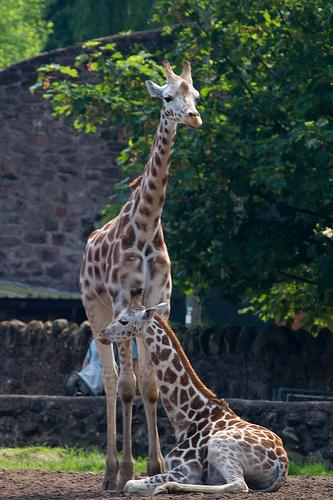Describe the background elements in the image, such as the walls and vegetation. The background features a wall of rock and a stone fence, some green grass next to the wall, an arched stone wall, trees and leaves, and metal poles or pipes. What are the objects located behind the main subject (giraffes) in the image? Behind the giraffes, there is a person, green grass, trees, metal poles or pipes, and a stone wall with possible stone buildings. Specify the key areas of interest in the image and their significance. Key areas of interest include the giraffes, which are the main subjects, the person observing them from behind, and the stone wall and trees with green leaves that set the natural context for the scene. What actions or emotions are expressed by the giraffes in the image? One giraffe is laying on the ground and appears tired or resting, while the other giraffe is standing on the ground. Mention any noteworthy colors and textures present in the image. Brown spots and patterning on the giraffes, green leaves and grass, gray and dark tones in the stone walls, black dirt on the ground, and metallic appearance in the pipes or poles. Provide a brief description of the overall scene in the image. The image features two giraffes near each other, one standing and one laying on the ground in a brown dirt area, surrounded by trees, grass, and a stone wall, with a person and metallic elements visible behind. What type of ground is the main subject resting upon? The giraffes are resting upon brown dirt ground, with areas of green grass around them near the stone wall. Summarize the image using a single sentence. Two giraffes, one resting on the ground and the other standing, are surrounded by vegetation and a stone wall, with a person observing from behind. 